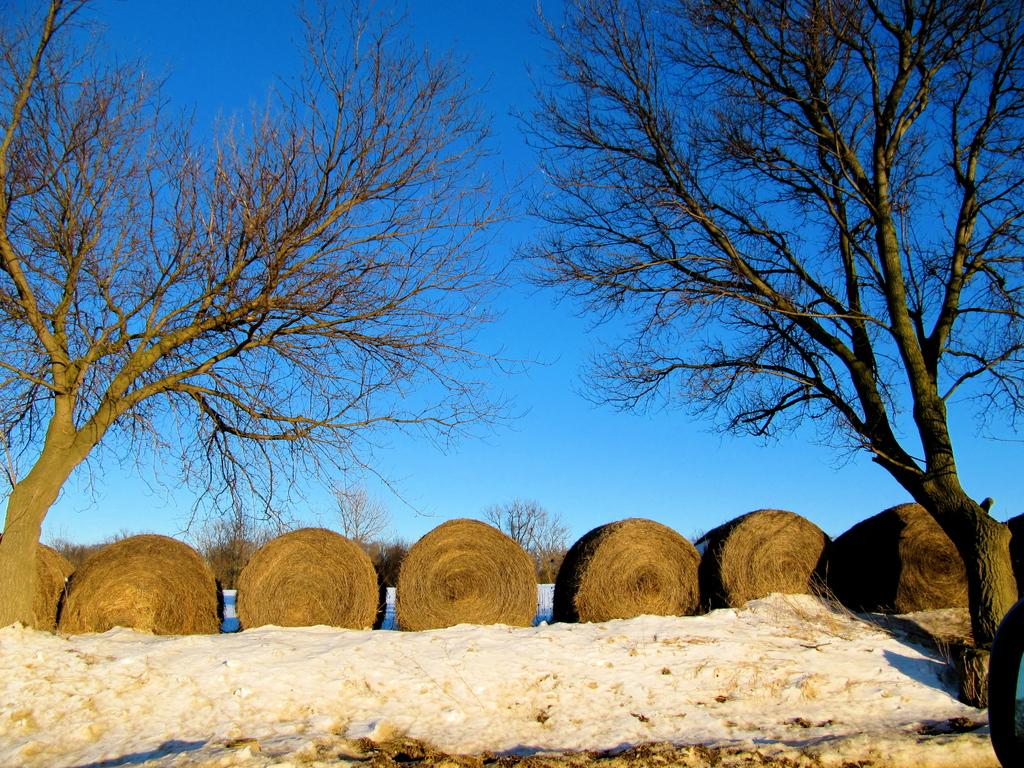What is the main subject of the image? The main subject of the image is a group of dried grass in the form of rolls on the ground. What is the weather like in the image? The weather is cold, as there is snow visible in the image. What type of vegetation can be seen in the image? There are trees in the image. What is the condition of the sky in the image? The sky is cloudy in the image. Can you see a snail crawling on the dried grass in the image? There is no snail visible in the image; it only features a group of dried grass rolls, snow, trees, and a cloudy sky. Is there a kettle boiling water in the image? There is no kettle present in the image. 